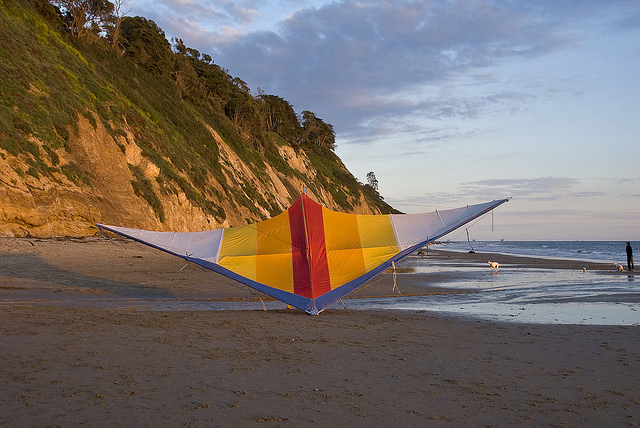What are the colors of the kite in the image? The kite in the image boasts a vibrant color palette, including shades of yellow, red, and blue, creating a visually striking contrast against the sandy beach. Describe the surroundings where the kite is located. The kite is situated on a sandy beach that stretches out to meet a gentle, serene ocean. To the left, there are picturesque cliffs covered with lush greenery, making for a stunning backdrop that enhances the beauty of the scene. The overall atmosphere is peaceful and inviting, suggesting a perfect day for flying kites. 